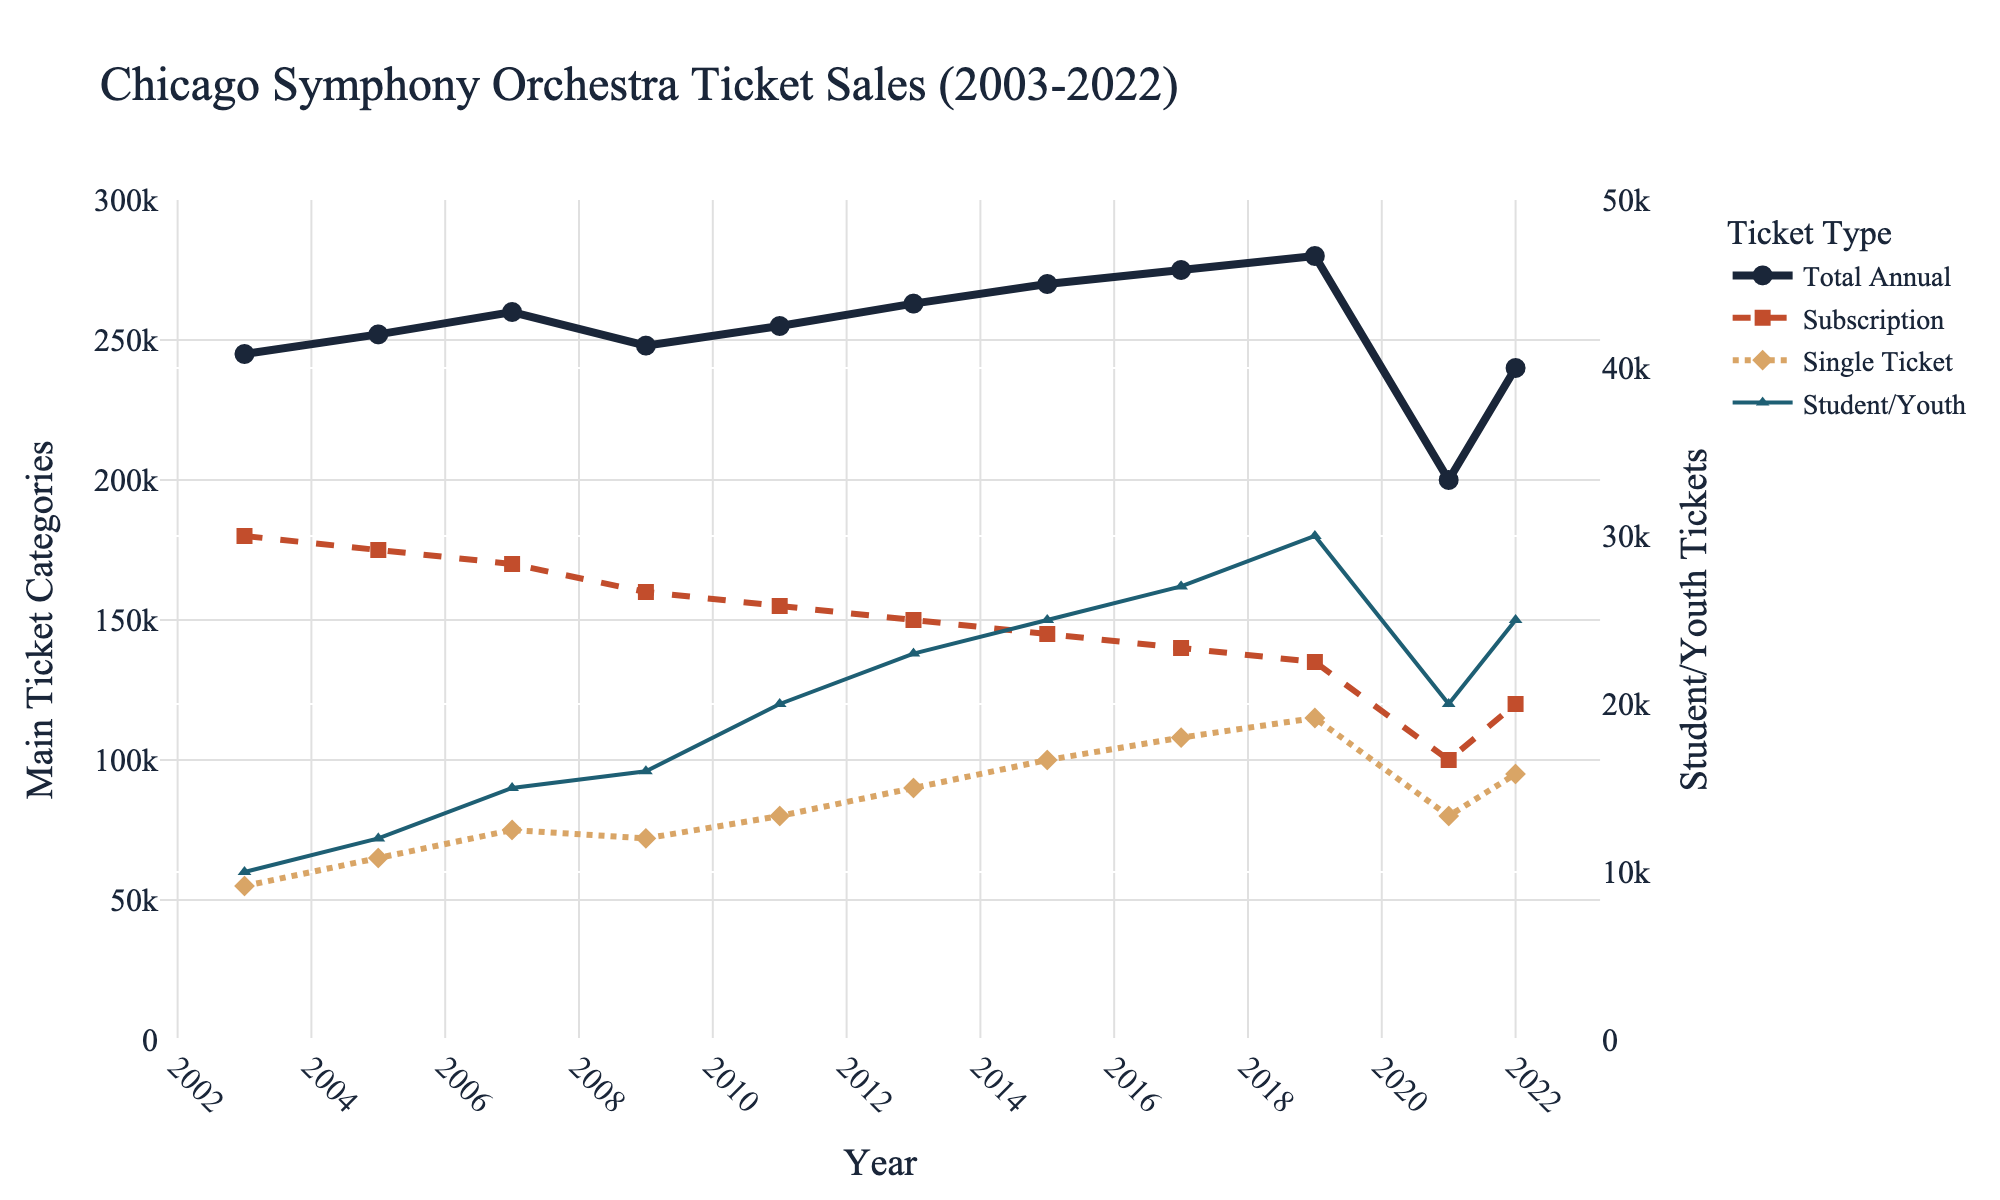What year had the highest total annual ticket sales? The highest total annual ticket sales were achieved in 2019, where the plot shows the peak of the main blue line.
Answer: 2019 What is the difference in subscription sales between 2003 and 2019? Subscription sales in 2003 were 180,000 tickets, and in 2019 they were 135,000 tickets. The difference is 180,000 - 135,000.
Answer: 45,000 Which ticket type showed an increasing trend from 2003 to 2019? Subscription and student/youth ticket sales both declined, while single ticket sales showed a clear trend of increasing from 55,000 in 2003 to 115,000 in 2019.
Answer: Single Ticket Sales What is the sum of single ticket and student/youth ticket sales in 2022? In 2022, single ticket sales were 95,000 and student/youth ticket sales were 25,000. Adding them gives 95,000 + 25,000.
Answer: 120,000 How did total annual ticket sales change from 2019 to 2021, and by how much? Total annual ticket sales decreased from 280,000 in 2019 to 200,000 in 2021. The change is 280,000 - 200,000.
Answer: 80,000 decrease Which ticket type had the smallest percentage change in sales from 2003 to 2022? Student/youth ticket sales had the smallest percentage change. They went from 10,000 in 2003 to 25,000 in 2022, which makes a relatively smaller impact compared to the percentage variations in other types.
Answer: Student/Youth Ticket Sales Describe the trend in student/youth ticket sales from 2003 to 2022. The sales of student/youth tickets started at 10,000 in 2003 and showed an overall upward trend, peaking at 30,000 in 2019, before decreasing slightly and settling at 25,000 in 2022.
Answer: Upward trend with slight recent drop In which year did single ticket sales surpass subscription sales? By tracking the intersection of the dashed red line (subscription) and the dotted tan line (single ticket), single ticket sales first surpassed subscription sales in 2017.
Answer: 2017 What was the total increase in student/youth ticket sales from 2013 to 2019? Student/youth ticket sales were 23,000 in 2013 and increased to 30,000 in 2019. The total increase is 30,000 - 23,000.
Answer: 7,000 